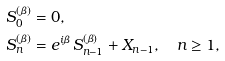Convert formula to latex. <formula><loc_0><loc_0><loc_500><loc_500>S _ { 0 } ^ { ( \beta ) } & = 0 , \\ S _ { n } ^ { ( \beta ) } & = e ^ { i \beta } \, S _ { n - 1 } ^ { ( \beta ) } + X _ { n - 1 } , \quad n \geq 1 ,</formula> 